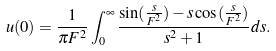<formula> <loc_0><loc_0><loc_500><loc_500>u ( 0 ) = \frac { 1 } { \pi F ^ { 2 } } \int _ { 0 } ^ { \infty } \frac { \sin ( \frac { s } { F ^ { 2 } } ) - s \cos ( \frac { s } { F ^ { 2 } } ) } { s ^ { 2 } + 1 } d s .</formula> 